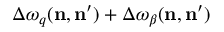<formula> <loc_0><loc_0><loc_500><loc_500>\Delta \omega _ { q } ( n , n ^ { \prime } ) + \Delta \omega _ { \beta } ( n , n ^ { \prime } )</formula> 